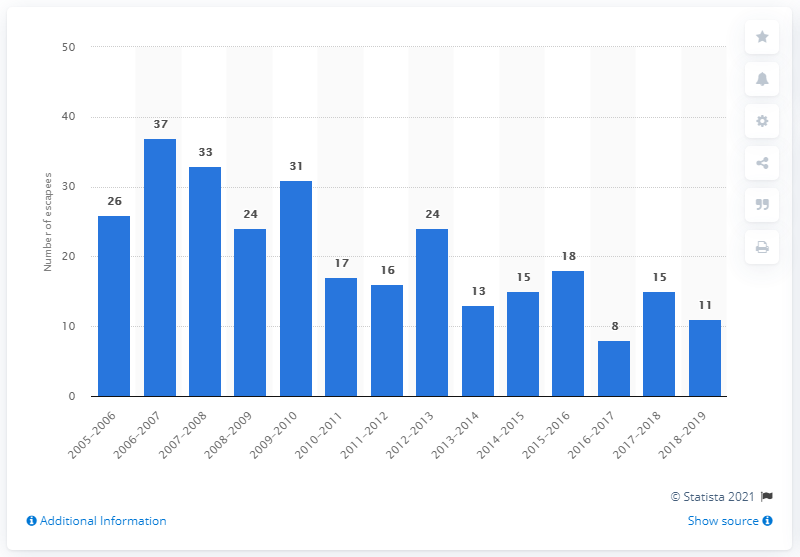Give some essential details in this illustration. During the fiscal year of 2019, eleven inmates escaped from federal prisons in Canada. 